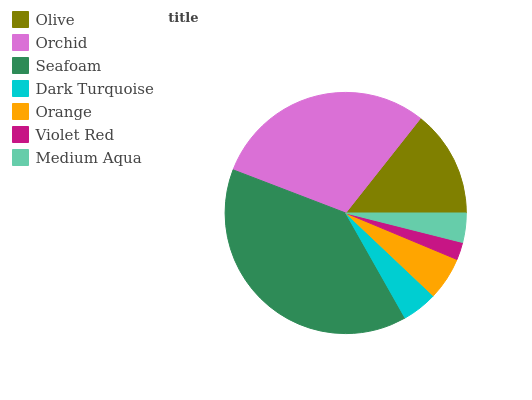Is Violet Red the minimum?
Answer yes or no. Yes. Is Seafoam the maximum?
Answer yes or no. Yes. Is Orchid the minimum?
Answer yes or no. No. Is Orchid the maximum?
Answer yes or no. No. Is Orchid greater than Olive?
Answer yes or no. Yes. Is Olive less than Orchid?
Answer yes or no. Yes. Is Olive greater than Orchid?
Answer yes or no. No. Is Orchid less than Olive?
Answer yes or no. No. Is Orange the high median?
Answer yes or no. Yes. Is Orange the low median?
Answer yes or no. Yes. Is Violet Red the high median?
Answer yes or no. No. Is Violet Red the low median?
Answer yes or no. No. 